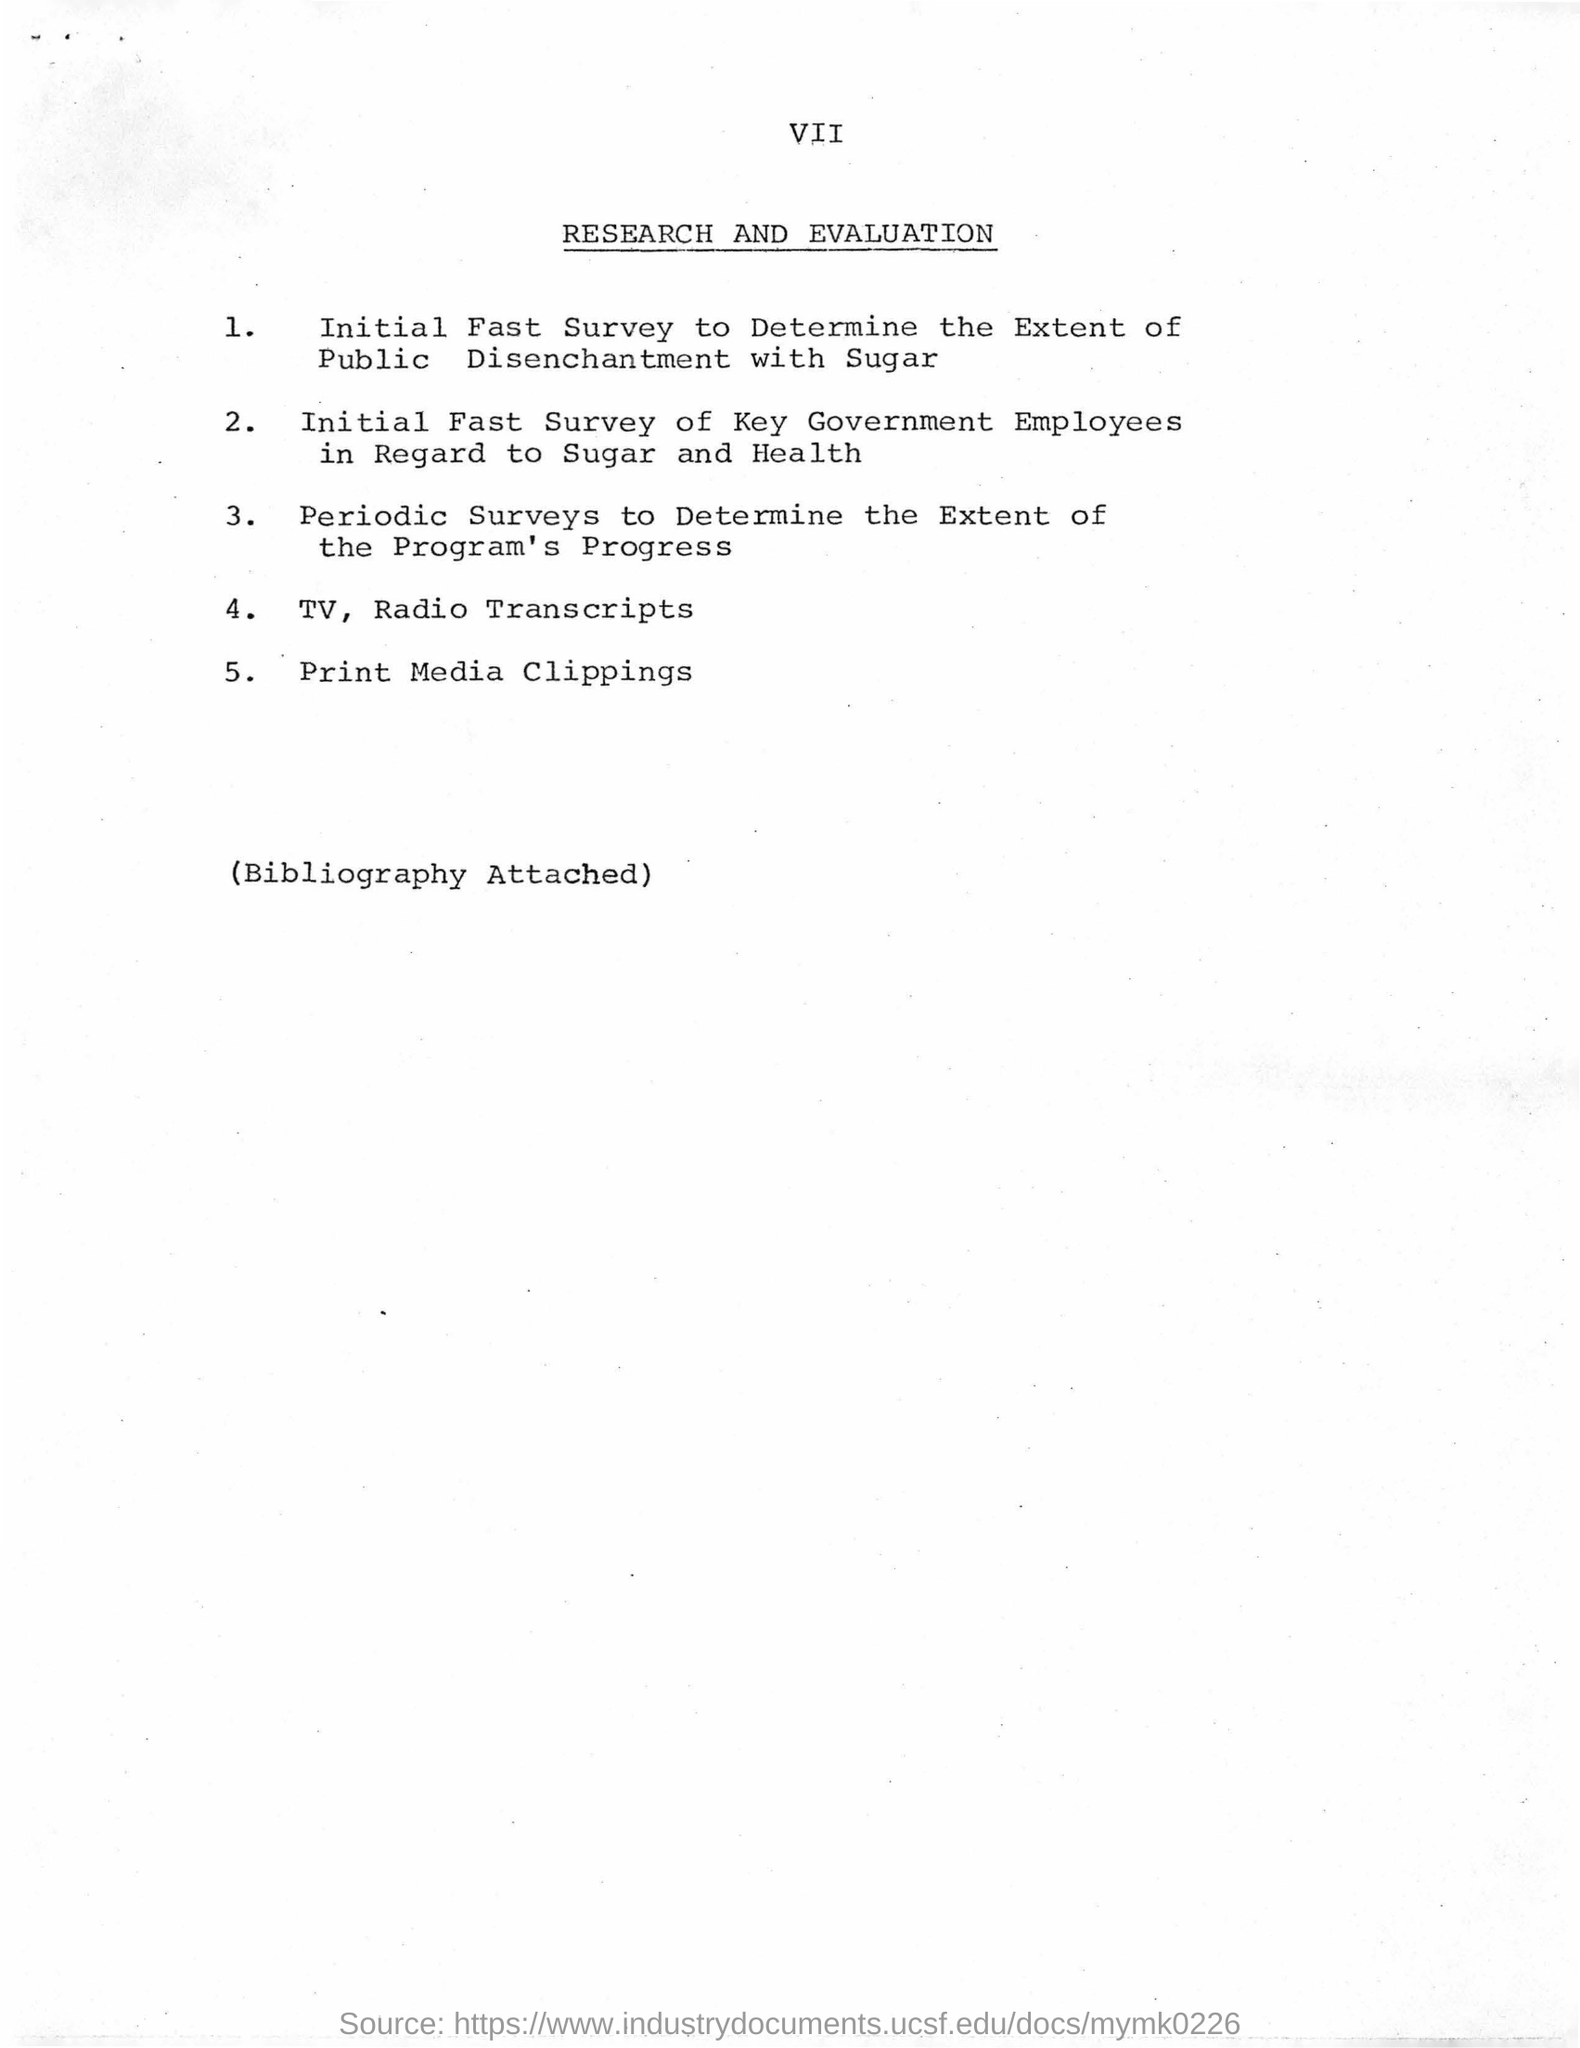Highlight a few significant elements in this photo. The fourth item in the list is "TV. The title of this sheet is "Research and Evaluation. 